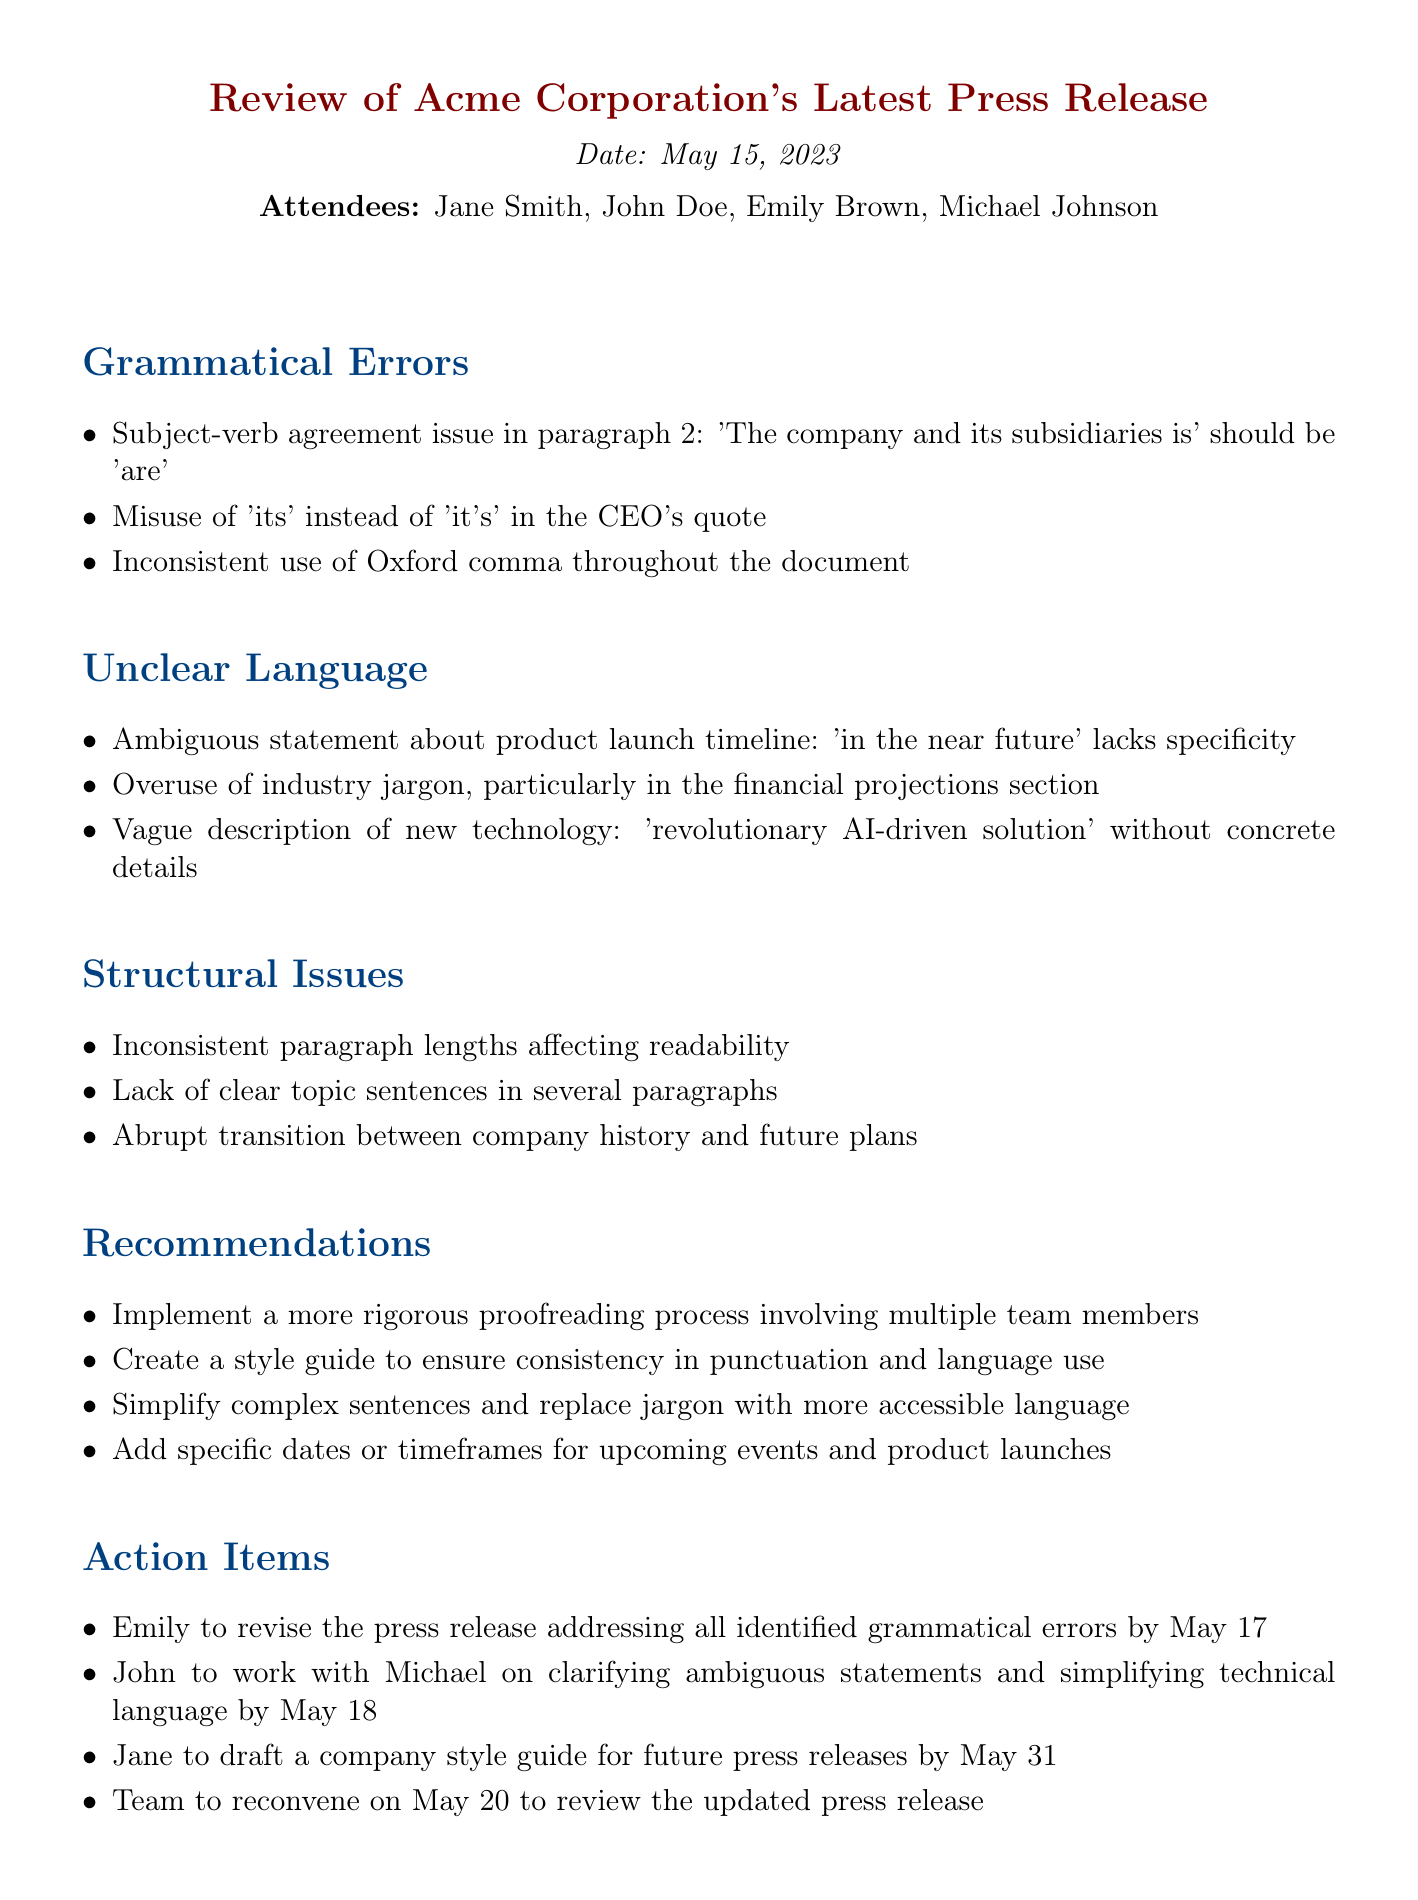What is the date of the meeting? The date of the meeting is stated upfront in the document as 'May 15, 2023'.
Answer: May 15, 2023 Who is the Communications Director? The document lists the attendees, and Jane Smith is identified as the Communications Director.
Answer: Jane Smith What grammatical issue is mentioned in paragraph 2? The document specifies a subject-verb agreement issue, stating 'The company and its subsidiaries is' should be 'are'.
Answer: Subject-verb agreement issue How many action items are listed? The document enumerates four action items that the team must address.
Answer: Four What recommendation is made regarding proofreading? One of the recommendations suggests implementing a more rigorous proofreading process involving multiple team members.
Answer: Implement a more rigorous proofreading process What specific feedback is given about the product launch timeline? The meeting minutes mention that the statement 'in the near future' lacks specificity.
Answer: Lacks specificity Which section contains overuse of jargon? The points under Unclear Language indicate an overuse of industry jargon in the financial projections section.
Answer: Financial projections section What is said about the company style guide? The action items include a task for Jane to draft a company style guide for future press releases by May 31.
Answer: Draft a company style guide by May 31 